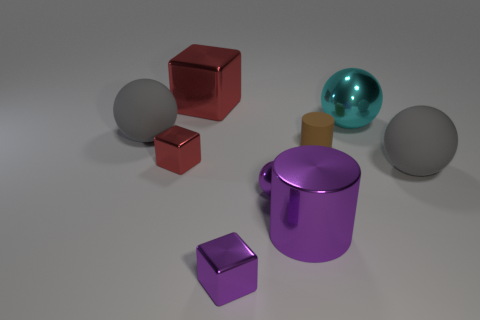Subtract all red cylinders. Subtract all yellow balls. How many cylinders are left? 2 Subtract all brown cylinders. How many cyan balls are left? 1 Add 9 big things. How many big reds exist? 0 Subtract all large gray matte things. Subtract all tiny red metal objects. How many objects are left? 6 Add 2 matte balls. How many matte balls are left? 4 Add 3 large blue rubber cylinders. How many large blue rubber cylinders exist? 3 Add 1 cylinders. How many objects exist? 10 Subtract all red blocks. How many blocks are left? 1 Subtract all big red metal blocks. How many blocks are left? 2 Subtract 0 yellow blocks. How many objects are left? 9 